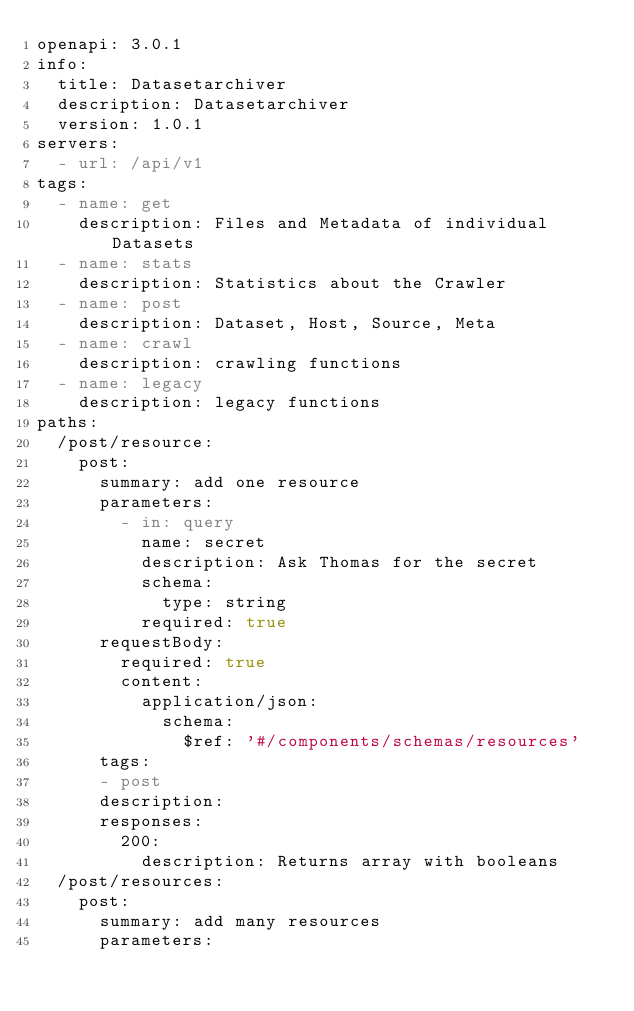Convert code to text. <code><loc_0><loc_0><loc_500><loc_500><_YAML_>openapi: 3.0.1
info:
  title: Datasetarchiver
  description: Datasetarchiver
  version: 1.0.1
servers:
  - url: /api/v1
tags:
  - name: get
    description: Files and Metadata of individual Datasets
  - name: stats
    description: Statistics about the Crawler
  - name: post
    description: Dataset, Host, Source, Meta
  - name: crawl
    description: crawling functions
  - name: legacy
    description: legacy functions
paths:
  /post/resource:
    post:
      summary: add one resource
      parameters:
        - in: query
          name: secret
          description: Ask Thomas for the secret
          schema:
            type: string
          required: true
      requestBody:
        required: true
        content:
          application/json:
            schema:
              $ref: '#/components/schemas/resources'
      tags:
      - post
      description:
      responses:
        200:
          description: Returns array with booleans
  /post/resources:
    post:
      summary: add many resources
      parameters:</code> 